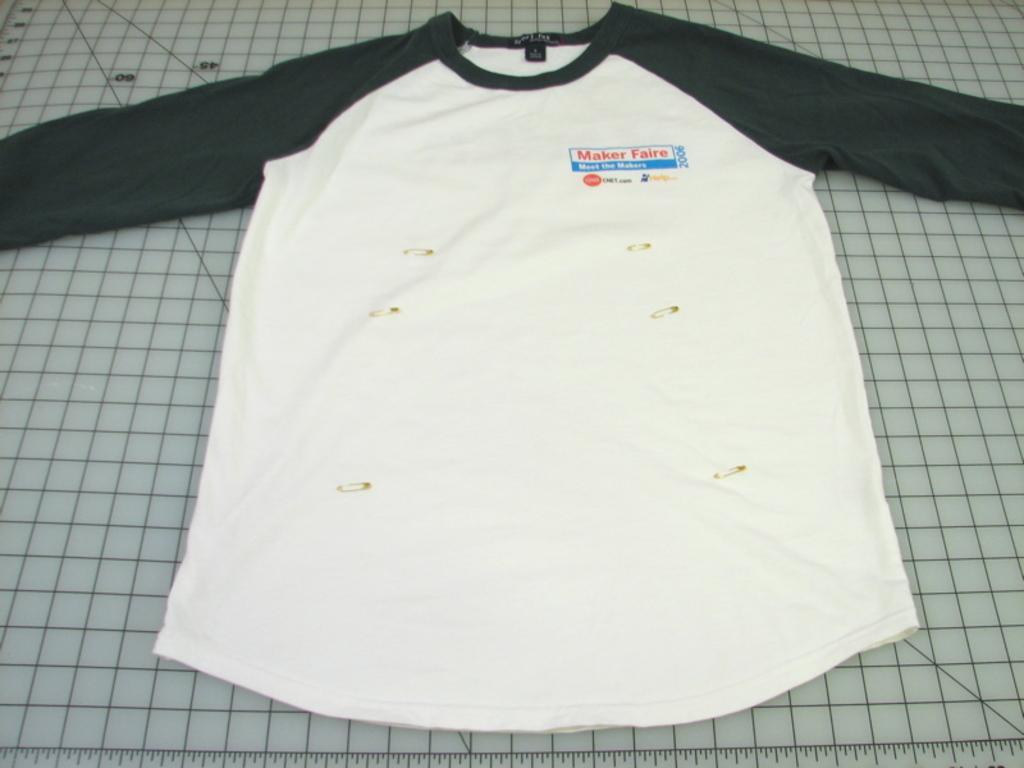Describe this image in one or two sentences. In this image, I can see a T-shirt, which is placed on the cutting mat. At the bottom of the image, that looks like a scale. 